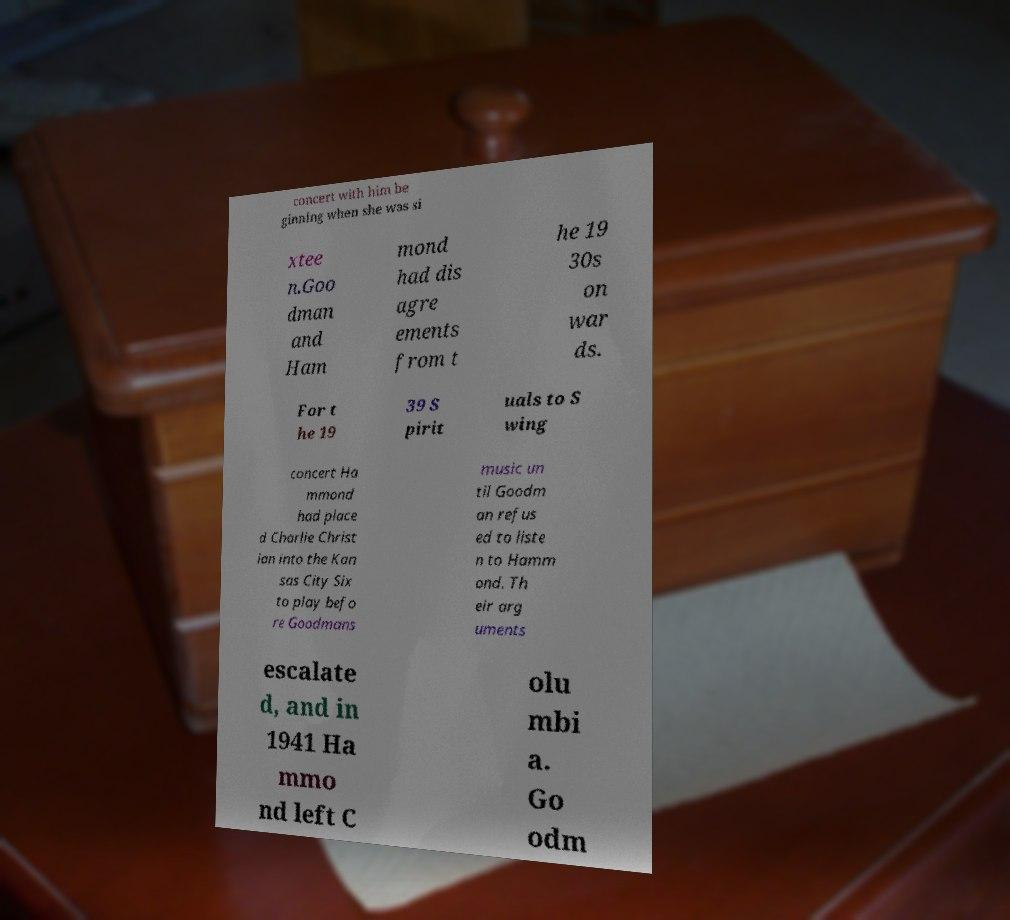For documentation purposes, I need the text within this image transcribed. Could you provide that? concert with him be ginning when she was si xtee n.Goo dman and Ham mond had dis agre ements from t he 19 30s on war ds. For t he 19 39 S pirit uals to S wing concert Ha mmond had place d Charlie Christ ian into the Kan sas City Six to play befo re Goodmans music un til Goodm an refus ed to liste n to Hamm ond. Th eir arg uments escalate d, and in 1941 Ha mmo nd left C olu mbi a. Go odm 